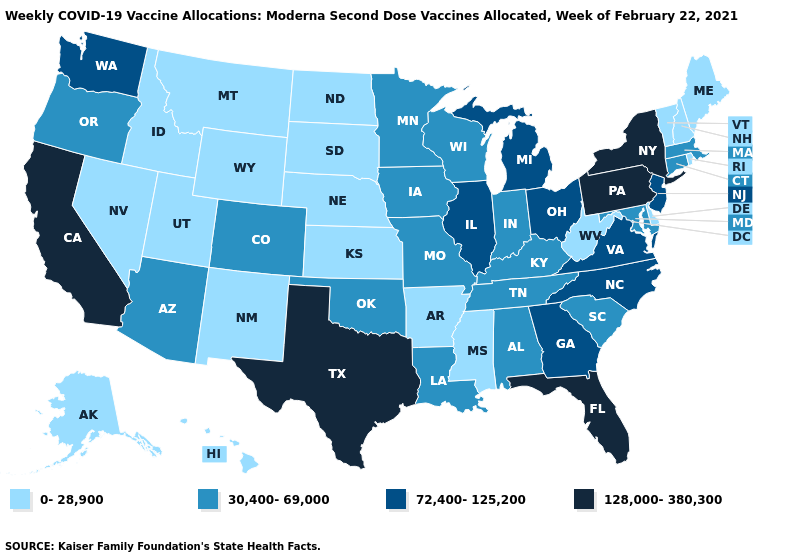Among the states that border Louisiana , does Arkansas have the highest value?
Answer briefly. No. What is the lowest value in states that border West Virginia?
Short answer required. 30,400-69,000. How many symbols are there in the legend?
Concise answer only. 4. Among the states that border Maryland , which have the highest value?
Be succinct. Pennsylvania. Does Nebraska have the same value as Connecticut?
Give a very brief answer. No. Does the map have missing data?
Give a very brief answer. No. What is the value of Michigan?
Write a very short answer. 72,400-125,200. Does Massachusetts have the lowest value in the Northeast?
Concise answer only. No. What is the lowest value in the USA?
Keep it brief. 0-28,900. Name the states that have a value in the range 72,400-125,200?
Short answer required. Georgia, Illinois, Michigan, New Jersey, North Carolina, Ohio, Virginia, Washington. Name the states that have a value in the range 30,400-69,000?
Give a very brief answer. Alabama, Arizona, Colorado, Connecticut, Indiana, Iowa, Kentucky, Louisiana, Maryland, Massachusetts, Minnesota, Missouri, Oklahoma, Oregon, South Carolina, Tennessee, Wisconsin. What is the highest value in the West ?
Quick response, please. 128,000-380,300. Name the states that have a value in the range 30,400-69,000?
Keep it brief. Alabama, Arizona, Colorado, Connecticut, Indiana, Iowa, Kentucky, Louisiana, Maryland, Massachusetts, Minnesota, Missouri, Oklahoma, Oregon, South Carolina, Tennessee, Wisconsin. Does Missouri have the lowest value in the USA?
Concise answer only. No. 